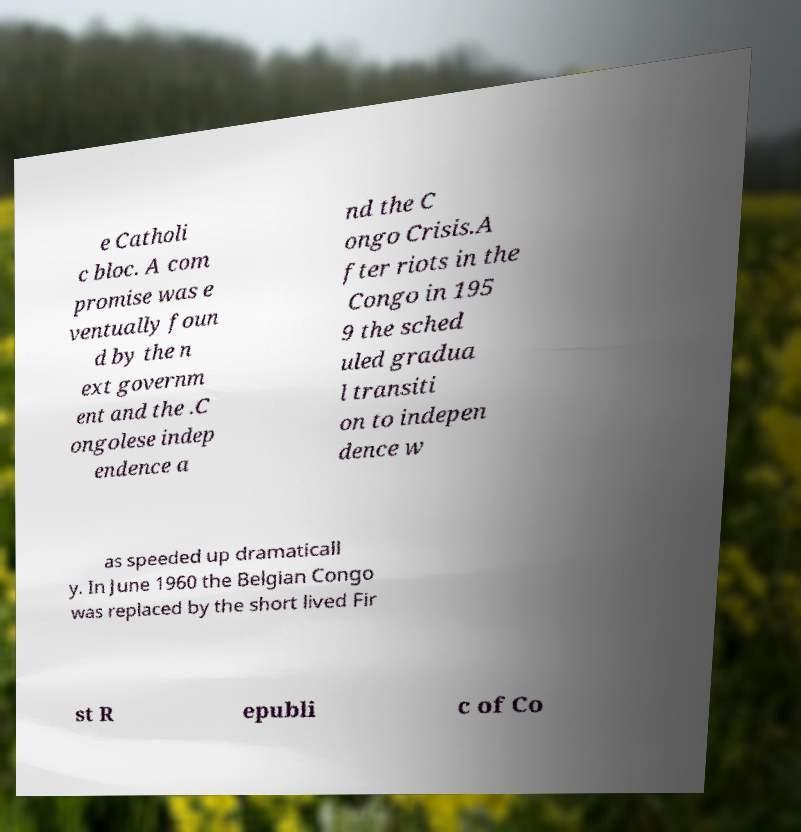Please identify and transcribe the text found in this image. e Catholi c bloc. A com promise was e ventually foun d by the n ext governm ent and the .C ongolese indep endence a nd the C ongo Crisis.A fter riots in the Congo in 195 9 the sched uled gradua l transiti on to indepen dence w as speeded up dramaticall y. In June 1960 the Belgian Congo was replaced by the short lived Fir st R epubli c of Co 